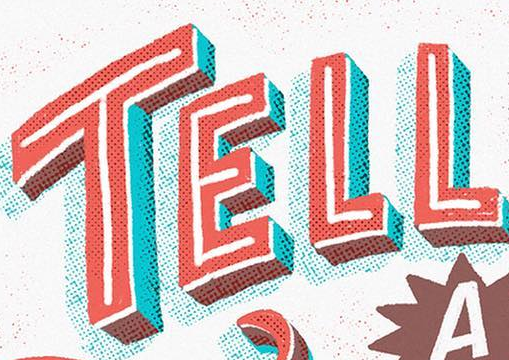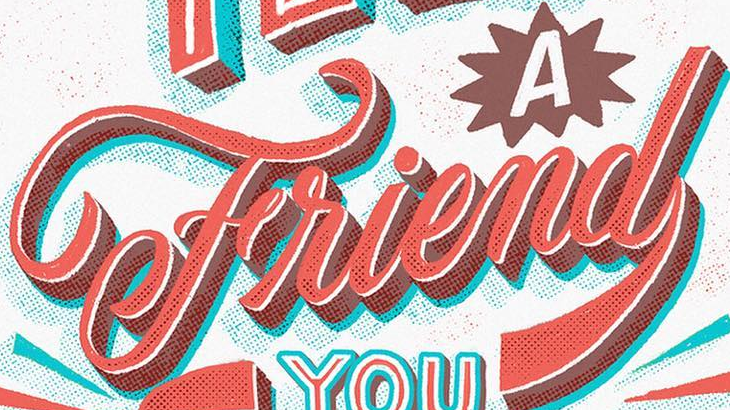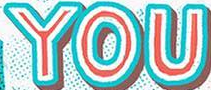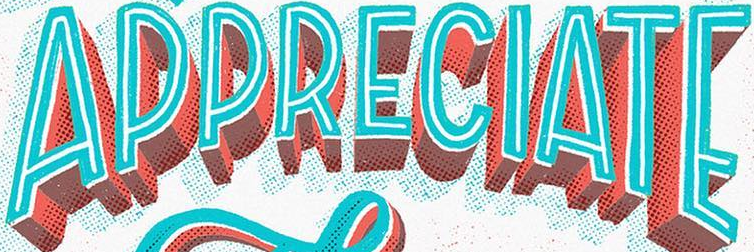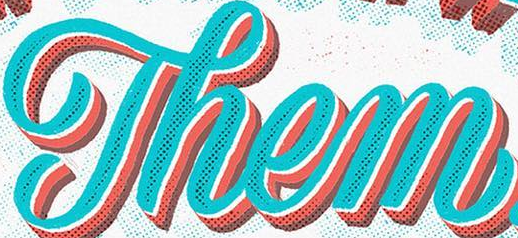What words can you see in these images in sequence, separated by a semicolon? TELL; Friend; YOU; APPRECIATE; Them 